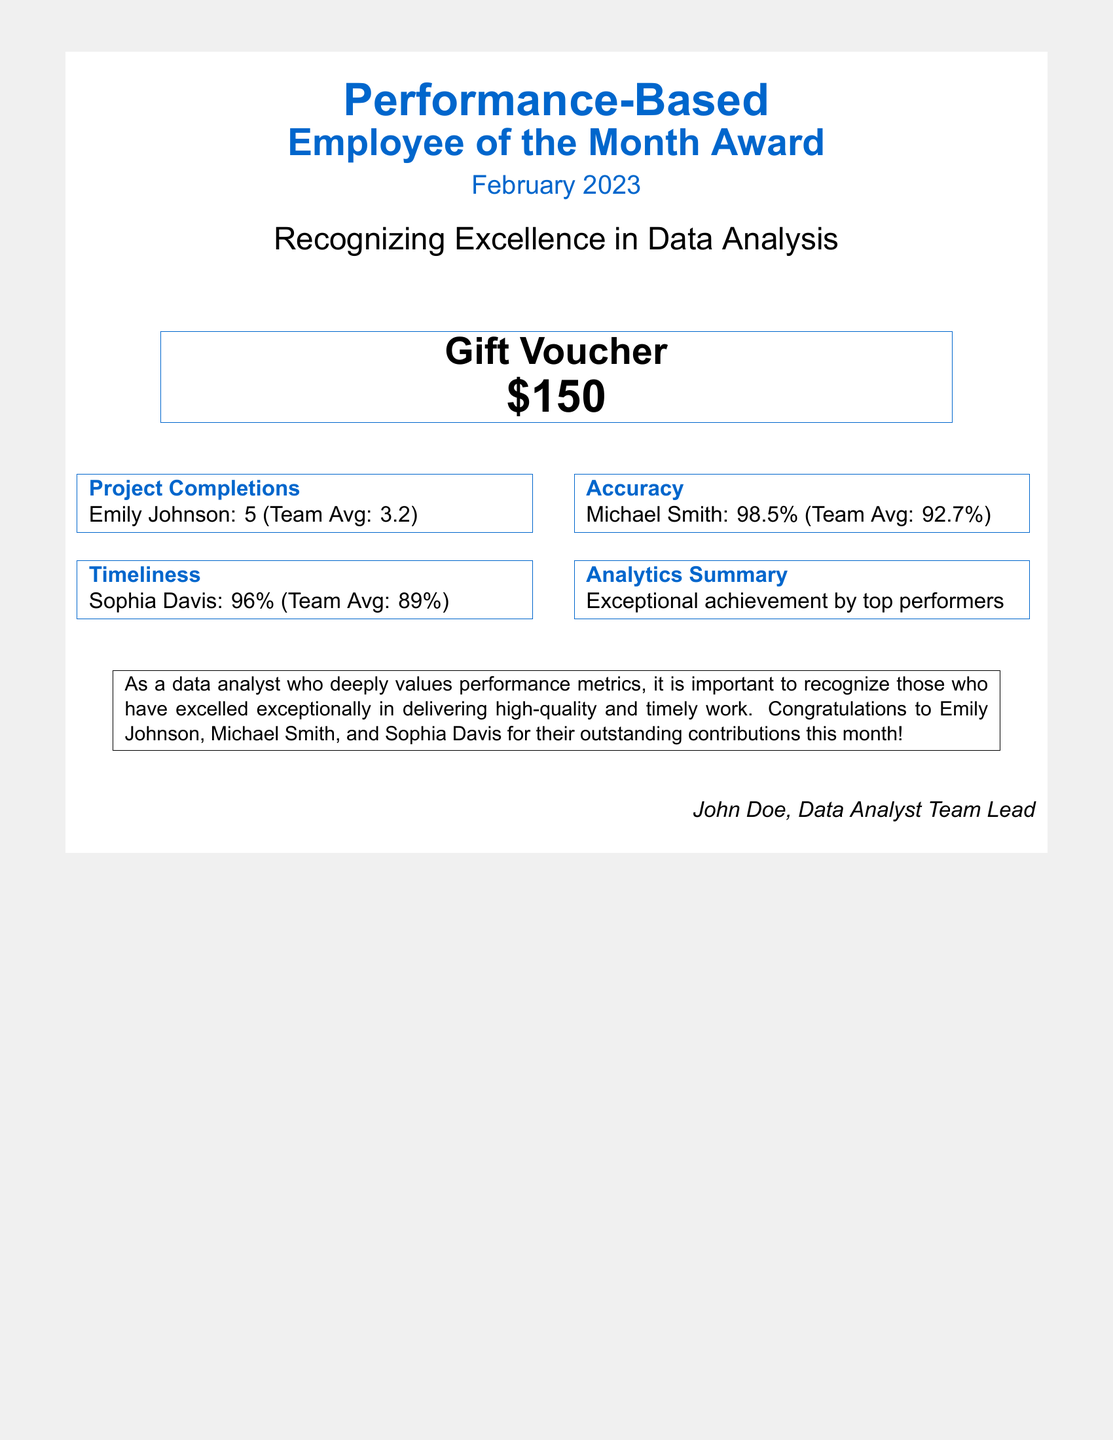What is the name of the Employee of the Month for February 2023? The document does not explicitly state a single Employee of the Month, but recognizes three individuals for their contributions.
Answer: Emily Johnson, Michael Smith, Sophia Davis What is the gift voucher amount? The document specifies the monetary value of the gift voucher presented in recognition of the employees.
Answer: $150 What was Emily Johnson's project completion count? The document details Emily Johnson's performance in terms of project completions compared to the team average.
Answer: 5 What percentage accuracy did Michael Smith achieve? The document provides Michael Smith's accuracy metric in relation to the team average.
Answer: 98.5% What was the team average for timeliness? The document presents a performance metric for timeliness and compares it to an individual performer.
Answer: 89% How many project completions did the team average? The document states the average number of project completions that the team achieved compared to an individual performer.
Answer: 3.2 Who is the author of the document? The document includes the name of the individual who authored the recognition for the performances.
Answer: John Doe What is the color used for headings in the document? The document uses a specific color for headings, which is visually distinct.
Answer: dataBlue 